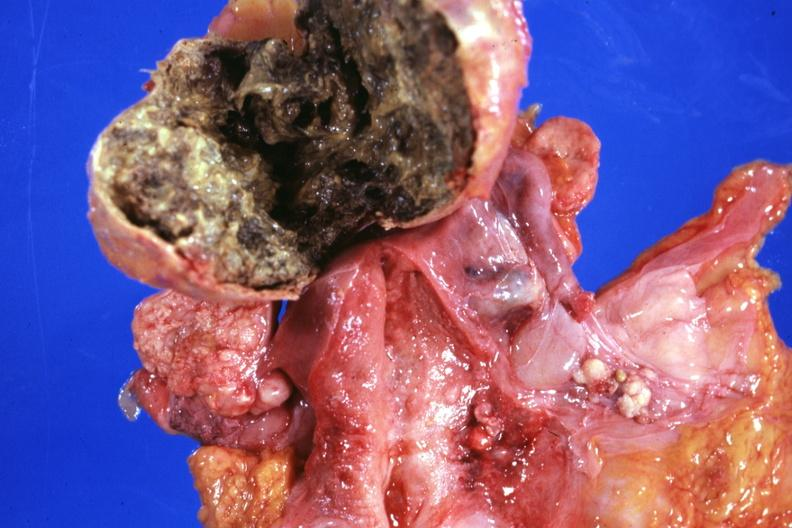s female reproductive present?
Answer the question using a single word or phrase. Yes 